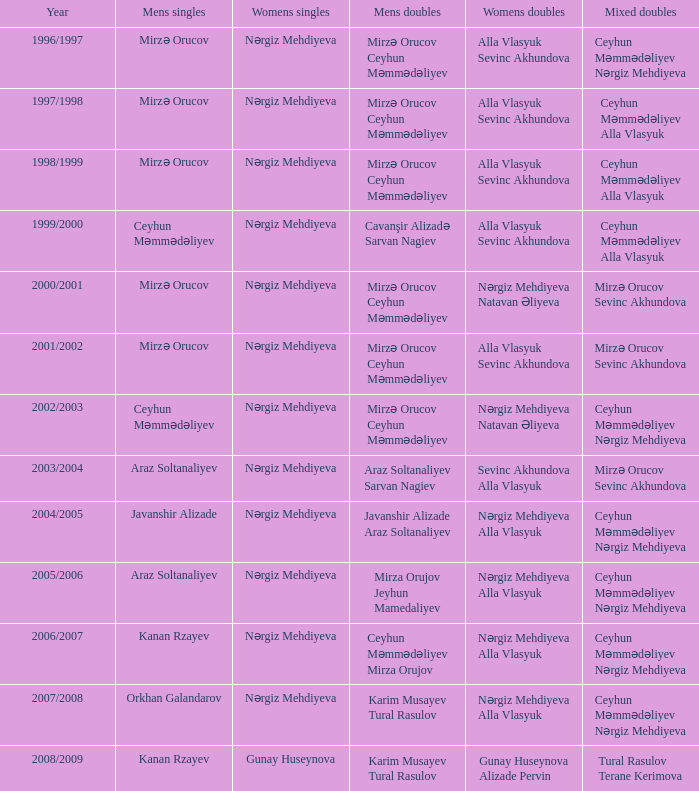Parse the table in full. {'header': ['Year', 'Mens singles', 'Womens singles', 'Mens doubles', 'Womens doubles', 'Mixed doubles'], 'rows': [['1996/1997', 'Mirzə Orucov', 'Nərgiz Mehdiyeva', 'Mirzə Orucov Ceyhun Məmmədəliyev', 'Alla Vlasyuk Sevinc Akhundova', 'Ceyhun Məmmədəliyev Nərgiz Mehdiyeva'], ['1997/1998', 'Mirzə Orucov', 'Nərgiz Mehdiyeva', 'Mirzə Orucov Ceyhun Məmmədəliyev', 'Alla Vlasyuk Sevinc Akhundova', 'Ceyhun Məmmədəliyev Alla Vlasyuk'], ['1998/1999', 'Mirzə Orucov', 'Nərgiz Mehdiyeva', 'Mirzə Orucov Ceyhun Məmmədəliyev', 'Alla Vlasyuk Sevinc Akhundova', 'Ceyhun Məmmədəliyev Alla Vlasyuk'], ['1999/2000', 'Ceyhun Məmmədəliyev', 'Nərgiz Mehdiyeva', 'Cavanşir Alizadə Sarvan Nagiev', 'Alla Vlasyuk Sevinc Akhundova', 'Ceyhun Məmmədəliyev Alla Vlasyuk'], ['2000/2001', 'Mirzə Orucov', 'Nərgiz Mehdiyeva', 'Mirzə Orucov Ceyhun Məmmədəliyev', 'Nərgiz Mehdiyeva Natavan Əliyeva', 'Mirzə Orucov Sevinc Akhundova'], ['2001/2002', 'Mirzə Orucov', 'Nərgiz Mehdiyeva', 'Mirzə Orucov Ceyhun Məmmədəliyev', 'Alla Vlasyuk Sevinc Akhundova', 'Mirzə Orucov Sevinc Akhundova'], ['2002/2003', 'Ceyhun Məmmədəliyev', 'Nərgiz Mehdiyeva', 'Mirzə Orucov Ceyhun Məmmədəliyev', 'Nərgiz Mehdiyeva Natavan Əliyeva', 'Ceyhun Məmmədəliyev Nərgiz Mehdiyeva'], ['2003/2004', 'Araz Soltanaliyev', 'Nərgiz Mehdiyeva', 'Araz Soltanaliyev Sarvan Nagiev', 'Sevinc Akhundova Alla Vlasyuk', 'Mirzə Orucov Sevinc Akhundova'], ['2004/2005', 'Javanshir Alizade', 'Nərgiz Mehdiyeva', 'Javanshir Alizade Araz Soltanaliyev', 'Nərgiz Mehdiyeva Alla Vlasyuk', 'Ceyhun Məmmədəliyev Nərgiz Mehdiyeva'], ['2005/2006', 'Araz Soltanaliyev', 'Nərgiz Mehdiyeva', 'Mirza Orujov Jeyhun Mamedaliyev', 'Nərgiz Mehdiyeva Alla Vlasyuk', 'Ceyhun Məmmədəliyev Nərgiz Mehdiyeva'], ['2006/2007', 'Kanan Rzayev', 'Nərgiz Mehdiyeva', 'Ceyhun Məmmədəliyev Mirza Orujov', 'Nərgiz Mehdiyeva Alla Vlasyuk', 'Ceyhun Məmmədəliyev Nərgiz Mehdiyeva'], ['2007/2008', 'Orkhan Galandarov', 'Nərgiz Mehdiyeva', 'Karim Musayev Tural Rasulov', 'Nərgiz Mehdiyeva Alla Vlasyuk', 'Ceyhun Məmmədəliyev Nərgiz Mehdiyeva'], ['2008/2009', 'Kanan Rzayev', 'Gunay Huseynova', 'Karim Musayev Tural Rasulov', 'Gunay Huseynova Alizade Pervin', 'Tural Rasulov Terane Kerimova']]} In the 2000/2001 period, what are the different values for women's doubles? Nərgiz Mehdiyeva Natavan Əliyeva. 